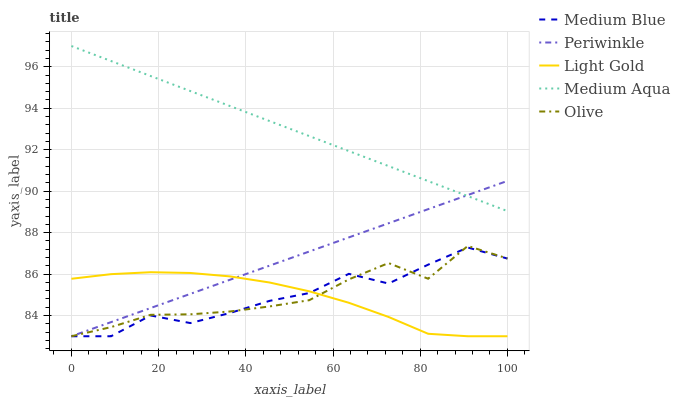Does Light Gold have the minimum area under the curve?
Answer yes or no. Yes. Does Medium Aqua have the maximum area under the curve?
Answer yes or no. Yes. Does Periwinkle have the minimum area under the curve?
Answer yes or no. No. Does Periwinkle have the maximum area under the curve?
Answer yes or no. No. Is Medium Aqua the smoothest?
Answer yes or no. Yes. Is Medium Blue the roughest?
Answer yes or no. Yes. Is Periwinkle the smoothest?
Answer yes or no. No. Is Periwinkle the roughest?
Answer yes or no. No. Does Periwinkle have the highest value?
Answer yes or no. No. Is Olive less than Medium Aqua?
Answer yes or no. Yes. Is Medium Aqua greater than Medium Blue?
Answer yes or no. Yes. Does Olive intersect Medium Aqua?
Answer yes or no. No. 